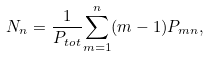Convert formula to latex. <formula><loc_0><loc_0><loc_500><loc_500>N _ { n } = \frac { 1 } { P _ { t o t } } { \sum _ { m = 1 } ^ { n } ( m - 1 ) P _ { m n } } ,</formula> 